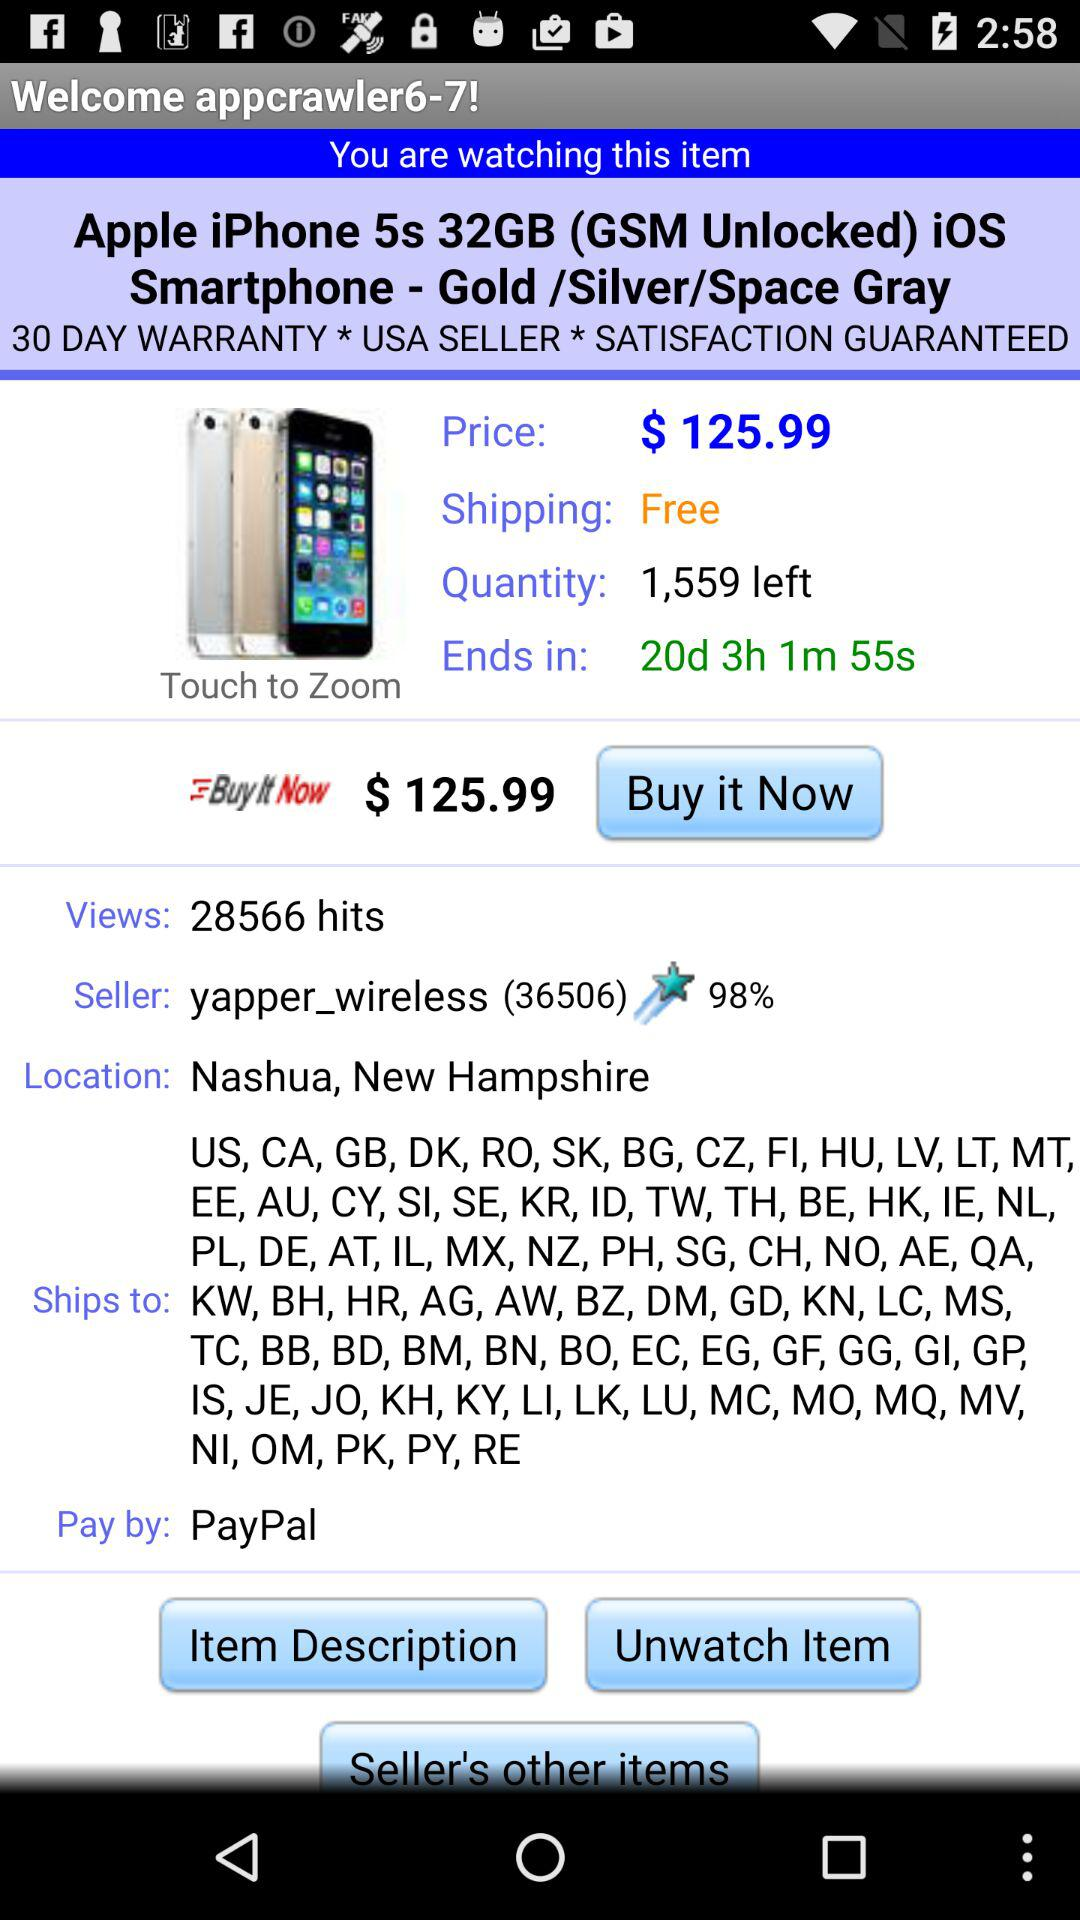How many quantities are left? There are 1,559 quantities left. 